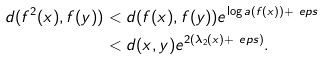<formula> <loc_0><loc_0><loc_500><loc_500>d ( f ^ { 2 } ( x ) , f ( y ) ) & < d ( f ( x ) , f ( y ) ) e ^ { \log a ( f ( x ) ) + \ e p s } \\ & < d ( x , y ) e ^ { 2 ( \lambda _ { 2 } ( x ) + \ e p s ) } .</formula> 